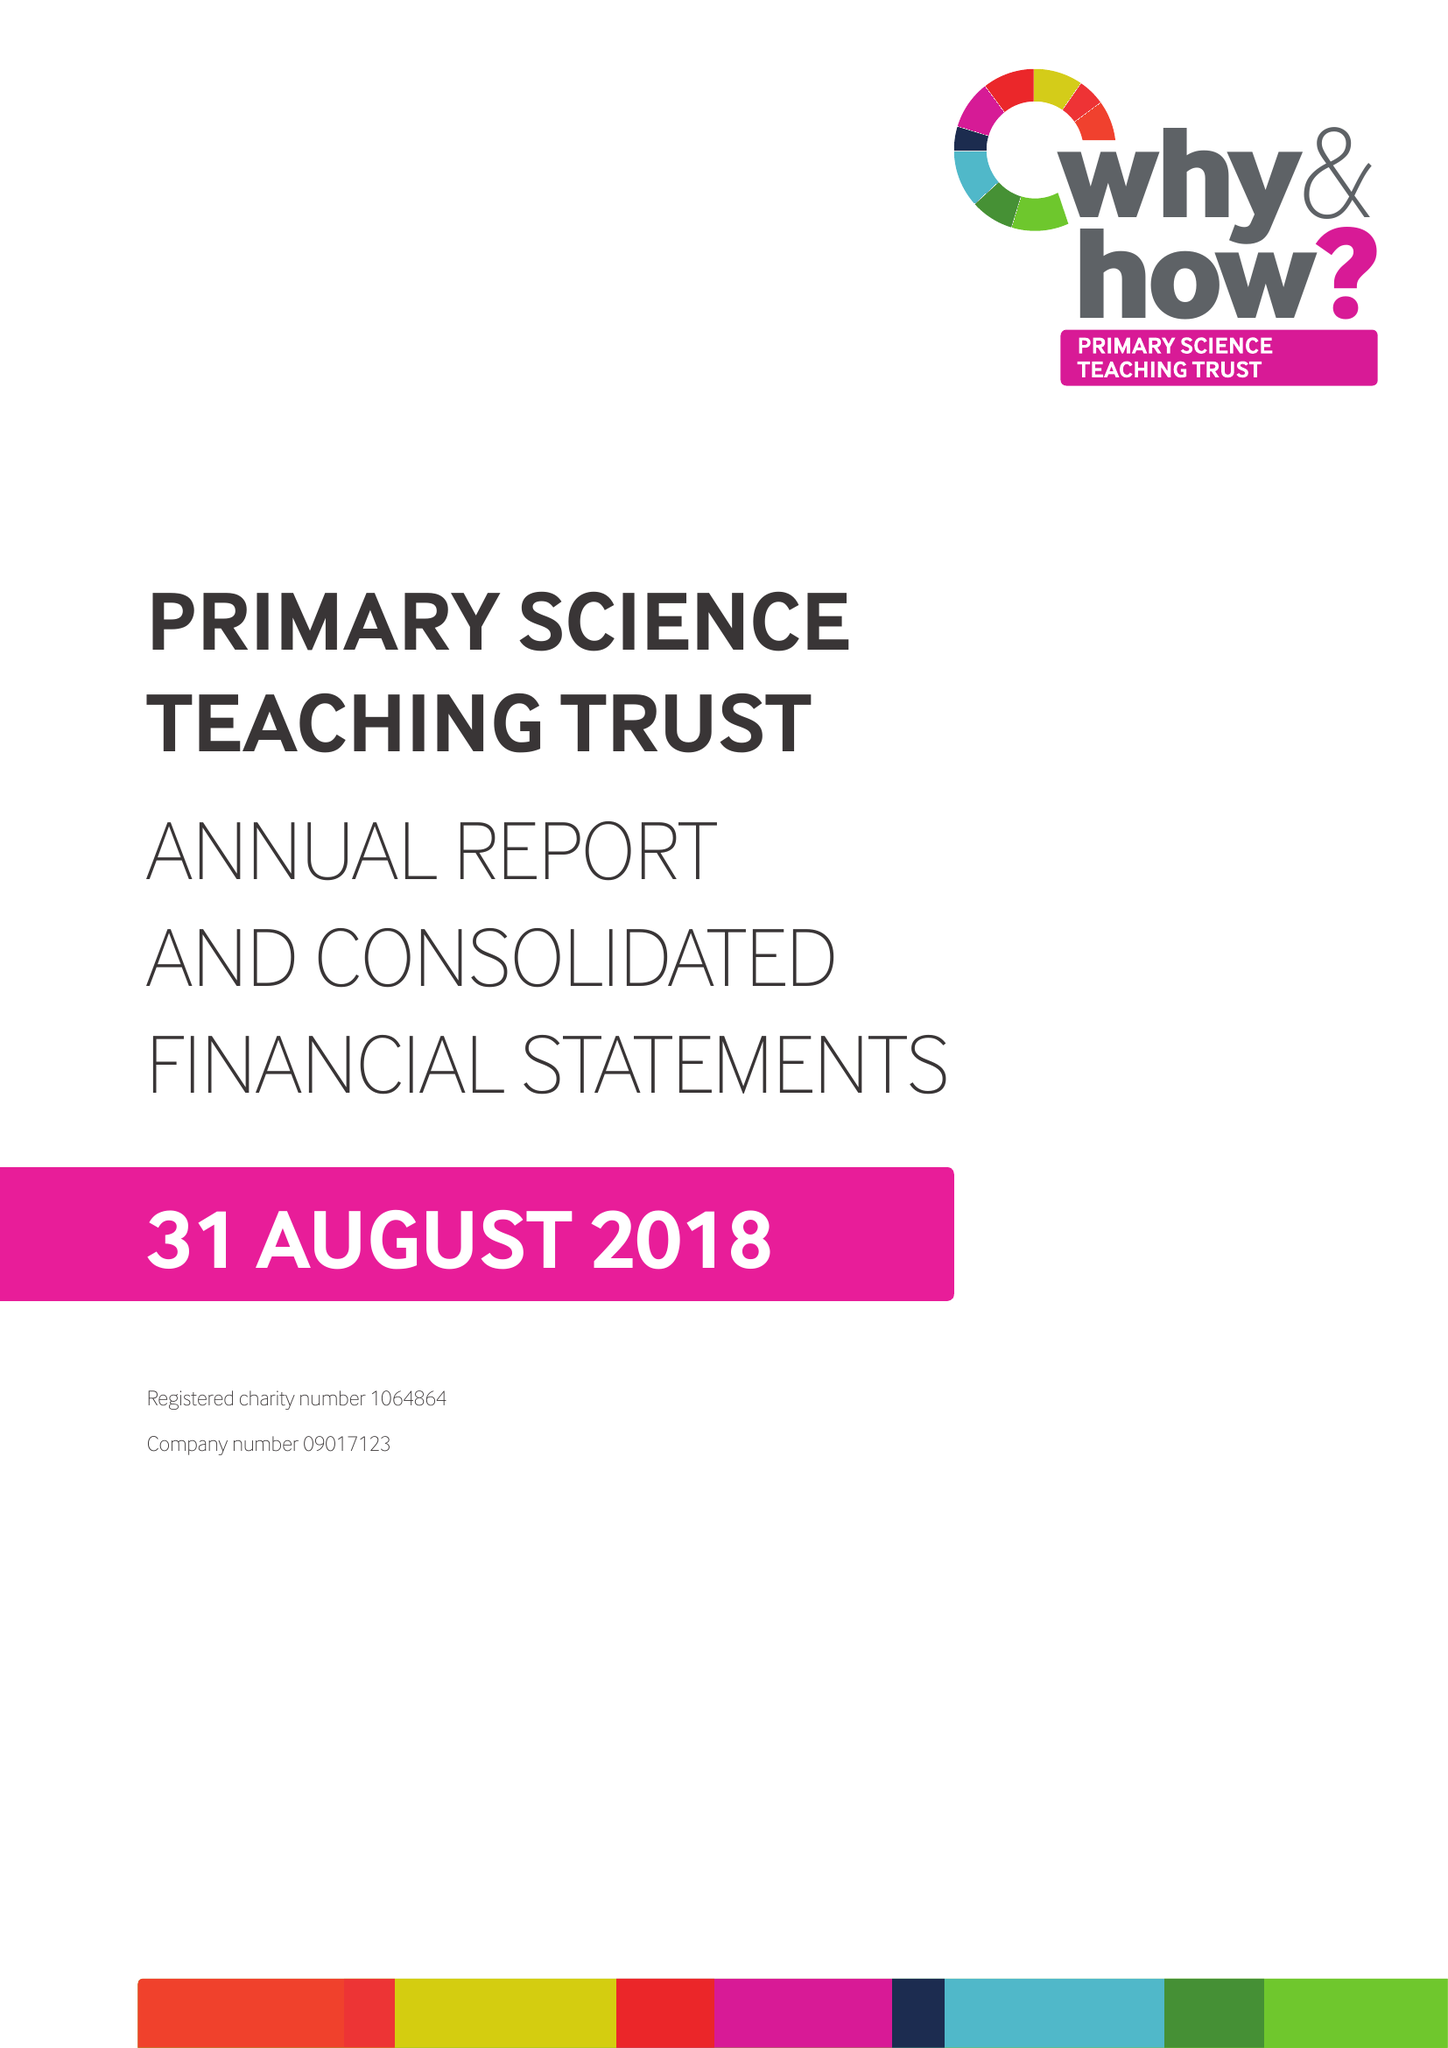What is the value for the spending_annually_in_british_pounds?
Answer the question using a single word or phrase. 2060070.00 